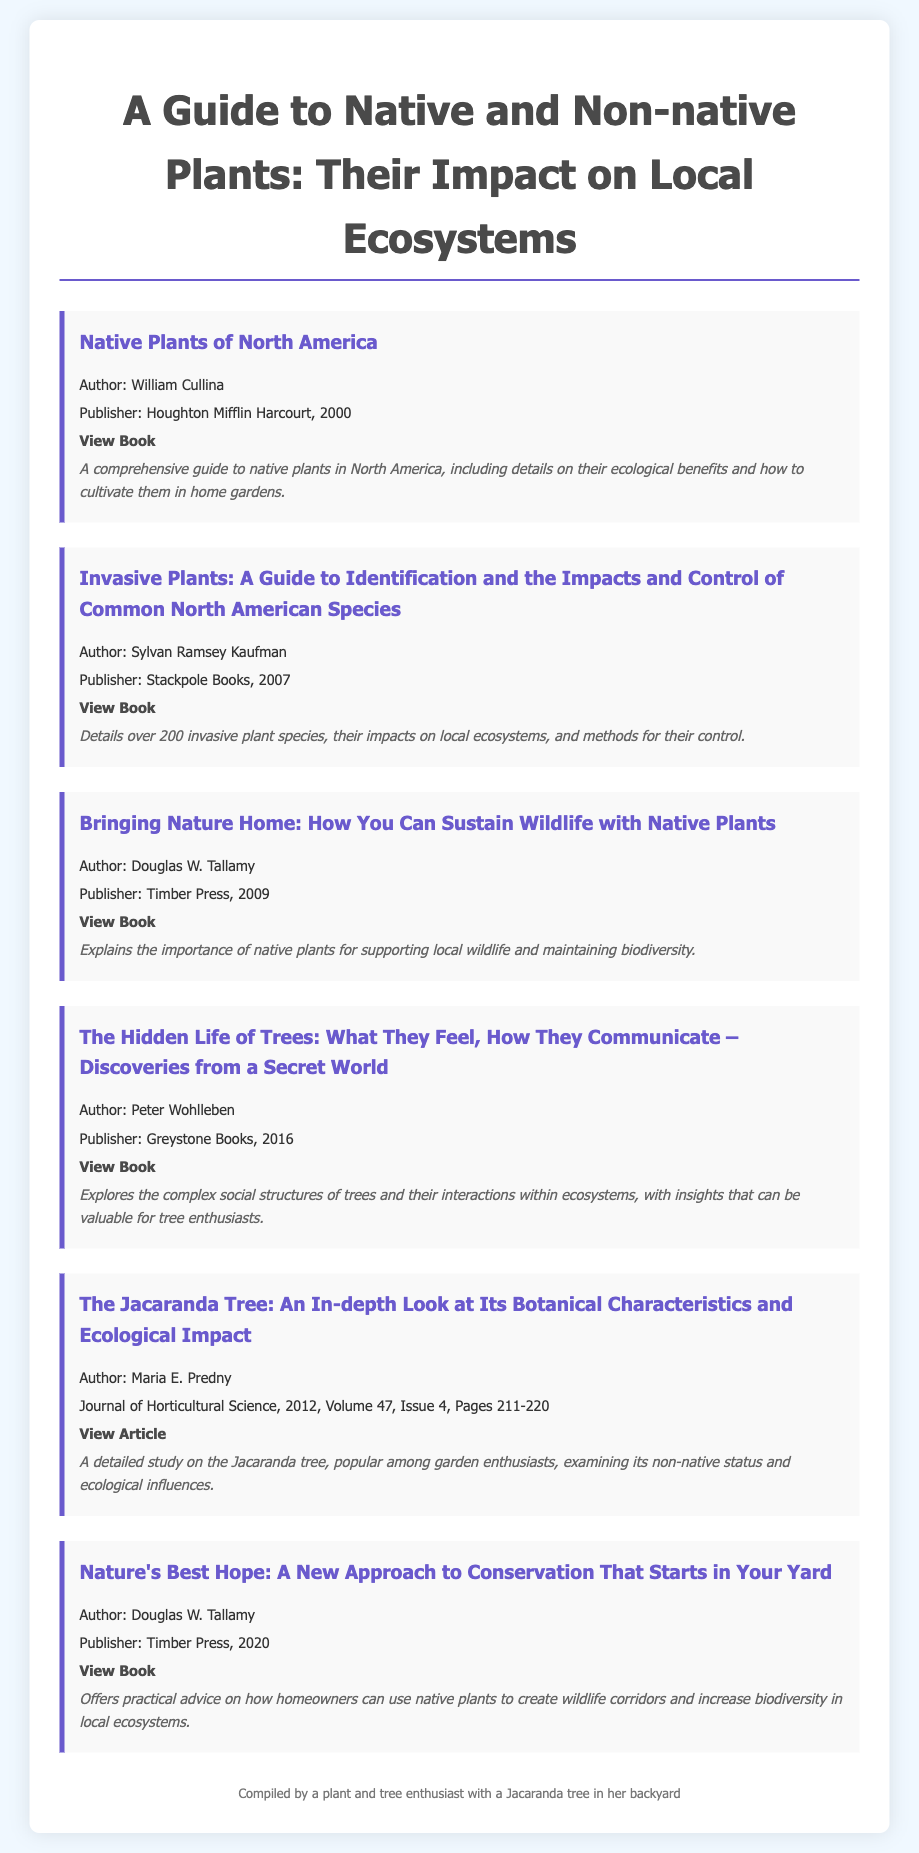What is the title of the first item in the bibliography? The title of the first item is the starting point of the bibliography list.
Answer: Native Plants of North America Who is the author of "Bringing Nature Home"? Knowing the author gives insight into the expertise behind the work.
Answer: Douglas W. Tallamy In what year was "Nature's Best Hope" published? The publication year provides context for the relevance of the information in the book.
Answer: 2020 How many invasive plant species are detailed in Kaufman's guide? This number reflects the comprehensiveness of the book on this topic.
Answer: Over 200 What is the primary focus of the article about the Jacaranda tree? Understanding the focus helps to clarify the content and its significance.
Answer: Ecological impact Which publisher released "The Hidden Life of Trees"? Identifying the publisher can indicate the type of audience the book aims to reach.
Answer: Greystone Books What volume and issue number is the Jacaranda tree article published in? This information is important for referencing the article properly.
Answer: Volume 47, Issue 4 Who published "Invasive Plants: A Guide to Identification"? Knowing the publisher provides context about the publication's authority and scope.
Answer: Stackpole Books 